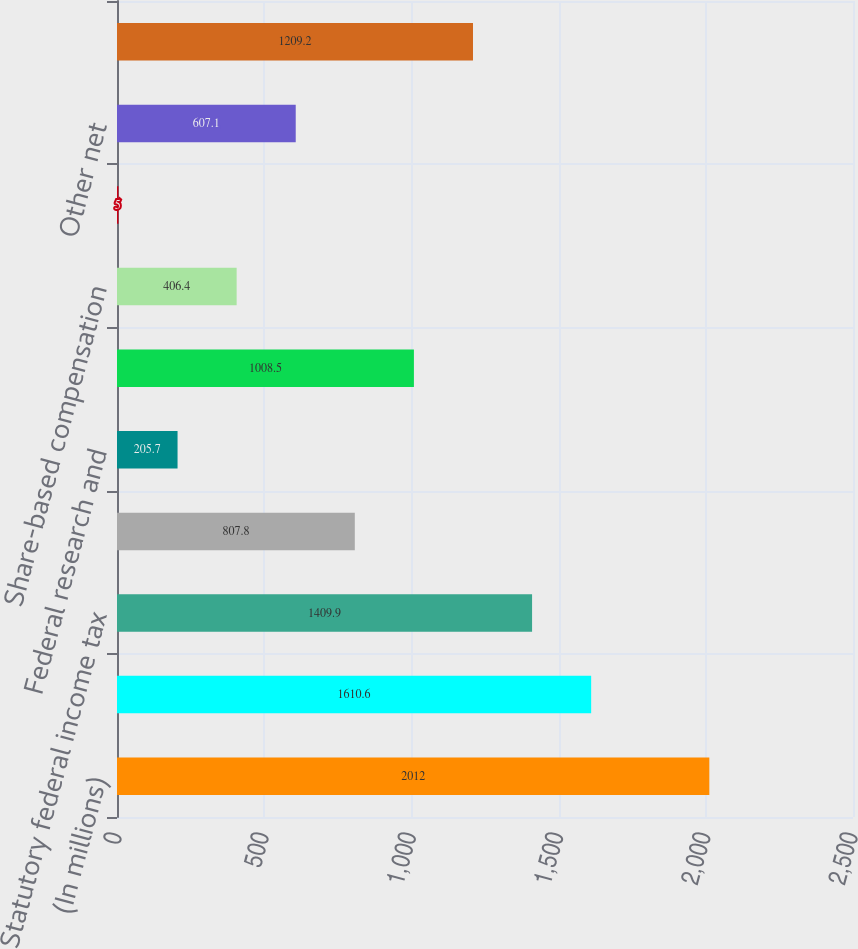Convert chart. <chart><loc_0><loc_0><loc_500><loc_500><bar_chart><fcel>(In millions)<fcel>Income from continuing<fcel>Statutory federal income tax<fcel>State income tax net of<fcel>Federal research and<fcel>Domestic production activities<fcel>Share-based compensation<fcel>Effects of non-US operations<fcel>Other net<fcel>Total provision for income<nl><fcel>2012<fcel>1610.6<fcel>1409.9<fcel>807.8<fcel>205.7<fcel>1008.5<fcel>406.4<fcel>5<fcel>607.1<fcel>1209.2<nl></chart> 